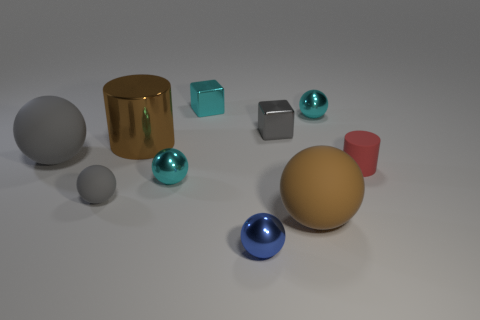What materials do the objects in the image appear to be made from? The objects exhibit a variety of materials. The cylinders and spheres seem to be made of glossy plastic or smooth metal. There's also a cube that looks like it could be either glass or a transparent plastic, given its clarity and light reflection. 